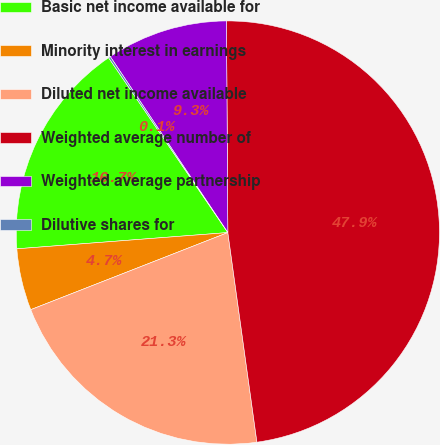Convert chart. <chart><loc_0><loc_0><loc_500><loc_500><pie_chart><fcel>Basic net income available for<fcel>Minority interest in earnings<fcel>Diluted net income available<fcel>Weighted average number of<fcel>Weighted average partnership<fcel>Dilutive shares for<nl><fcel>16.7%<fcel>4.71%<fcel>21.26%<fcel>47.91%<fcel>9.27%<fcel>0.15%<nl></chart> 